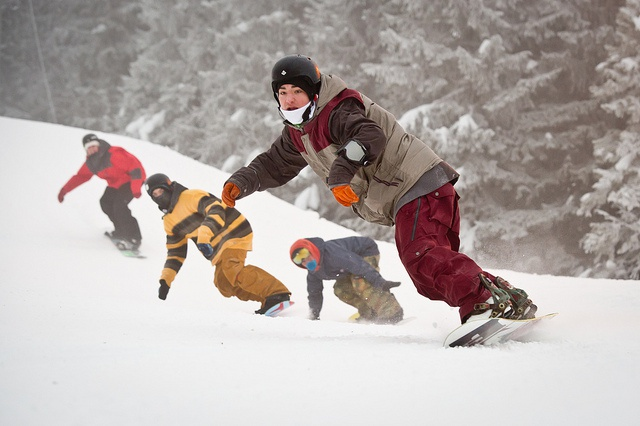Describe the objects in this image and their specific colors. I can see people in gray, maroon, black, and darkgray tones, people in gray and tan tones, people in gray and darkgray tones, people in gray, salmon, brown, and darkgray tones, and snowboard in gray, lightgray, and darkgray tones in this image. 